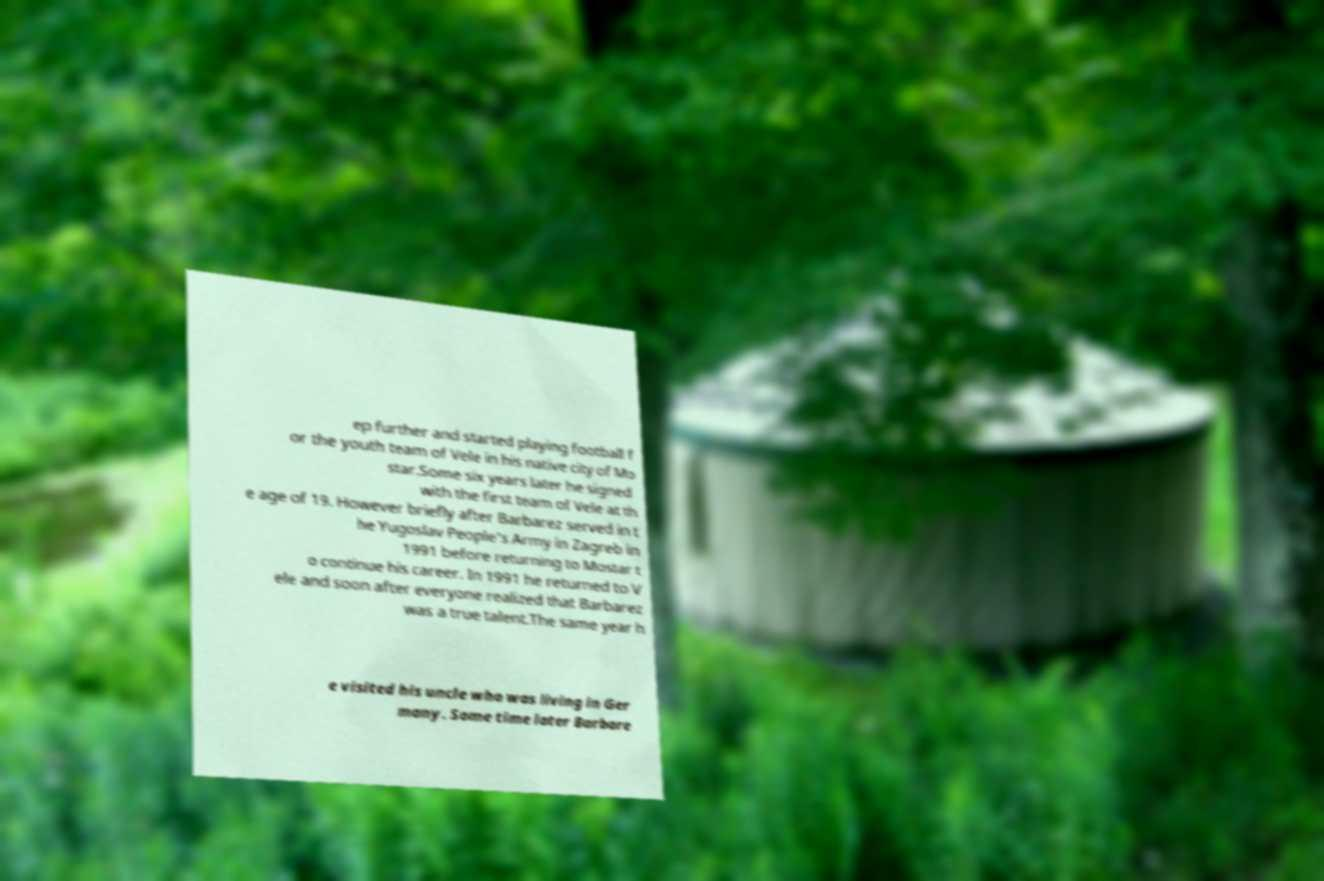For documentation purposes, I need the text within this image transcribed. Could you provide that? ep further and started playing football f or the youth team of Vele in his native city of Mo star.Some six years later he signed with the first team of Vele at th e age of 19. However briefly after Barbarez served in t he Yugoslav People's Army in Zagreb in 1991 before returning to Mostar t o continue his career. In 1991 he returned to V ele and soon after everyone realized that Barbarez was a true talent.The same year h e visited his uncle who was living in Ger many. Some time later Barbare 